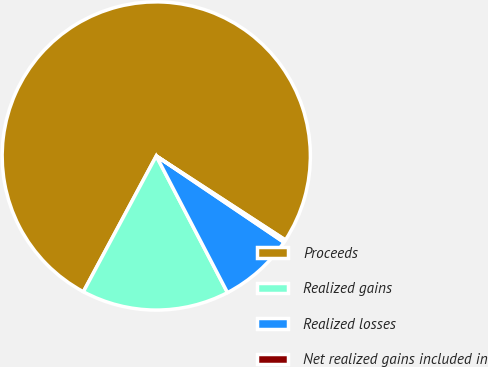Convert chart to OTSL. <chart><loc_0><loc_0><loc_500><loc_500><pie_chart><fcel>Proceeds<fcel>Realized gains<fcel>Realized losses<fcel>Net realized gains included in<nl><fcel>76.34%<fcel>15.49%<fcel>7.89%<fcel>0.28%<nl></chart> 